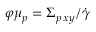<formula> <loc_0><loc_0><loc_500><loc_500>\varphi \mu _ { p } = \Sigma _ { p \, x y } / \dot { \gamma }</formula> 